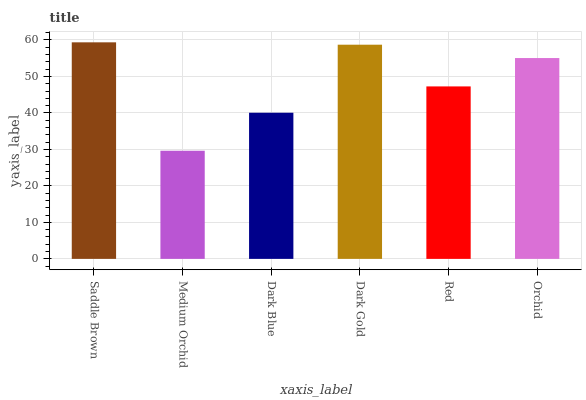Is Medium Orchid the minimum?
Answer yes or no. Yes. Is Saddle Brown the maximum?
Answer yes or no. Yes. Is Dark Blue the minimum?
Answer yes or no. No. Is Dark Blue the maximum?
Answer yes or no. No. Is Dark Blue greater than Medium Orchid?
Answer yes or no. Yes. Is Medium Orchid less than Dark Blue?
Answer yes or no. Yes. Is Medium Orchid greater than Dark Blue?
Answer yes or no. No. Is Dark Blue less than Medium Orchid?
Answer yes or no. No. Is Orchid the high median?
Answer yes or no. Yes. Is Red the low median?
Answer yes or no. Yes. Is Red the high median?
Answer yes or no. No. Is Orchid the low median?
Answer yes or no. No. 